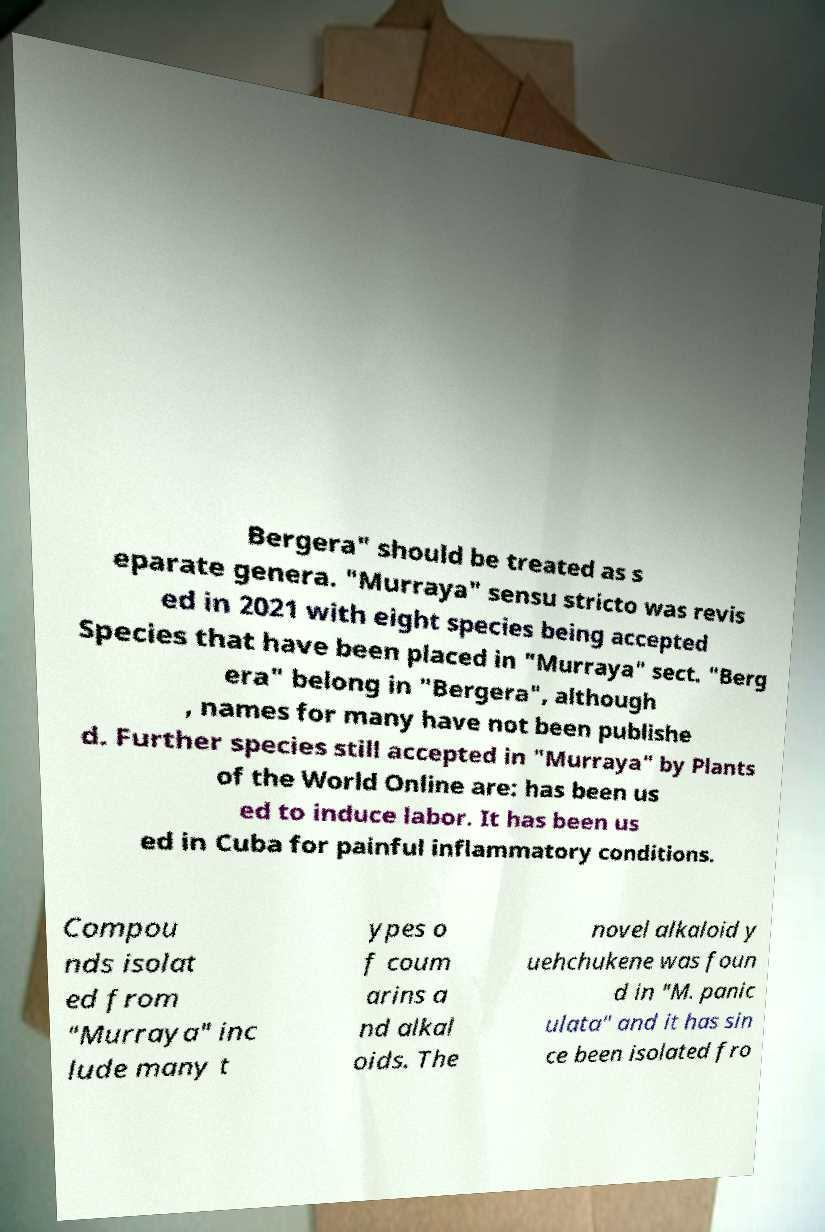Please identify and transcribe the text found in this image. Bergera" should be treated as s eparate genera. "Murraya" sensu stricto was revis ed in 2021 with eight species being accepted Species that have been placed in "Murraya" sect. "Berg era" belong in "Bergera", although , names for many have not been publishe d. Further species still accepted in "Murraya" by Plants of the World Online are: has been us ed to induce labor. It has been us ed in Cuba for painful inflammatory conditions. Compou nds isolat ed from "Murraya" inc lude many t ypes o f coum arins a nd alkal oids. The novel alkaloid y uehchukene was foun d in "M. panic ulata" and it has sin ce been isolated fro 